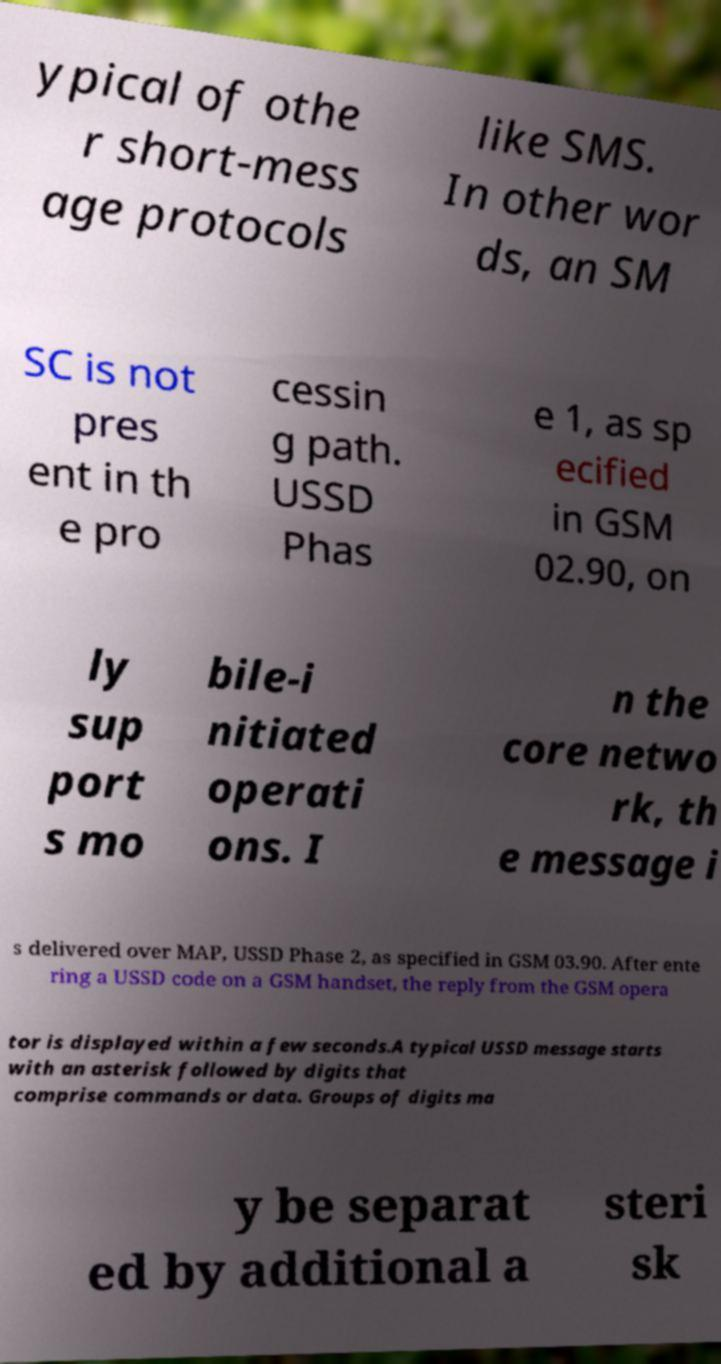What messages or text are displayed in this image? I need them in a readable, typed format. ypical of othe r short-mess age protocols like SMS. In other wor ds, an SM SC is not pres ent in th e pro cessin g path. USSD Phas e 1, as sp ecified in GSM 02.90, on ly sup port s mo bile-i nitiated operati ons. I n the core netwo rk, th e message i s delivered over MAP, USSD Phase 2, as specified in GSM 03.90. After ente ring a USSD code on a GSM handset, the reply from the GSM opera tor is displayed within a few seconds.A typical USSD message starts with an asterisk followed by digits that comprise commands or data. Groups of digits ma y be separat ed by additional a steri sk 